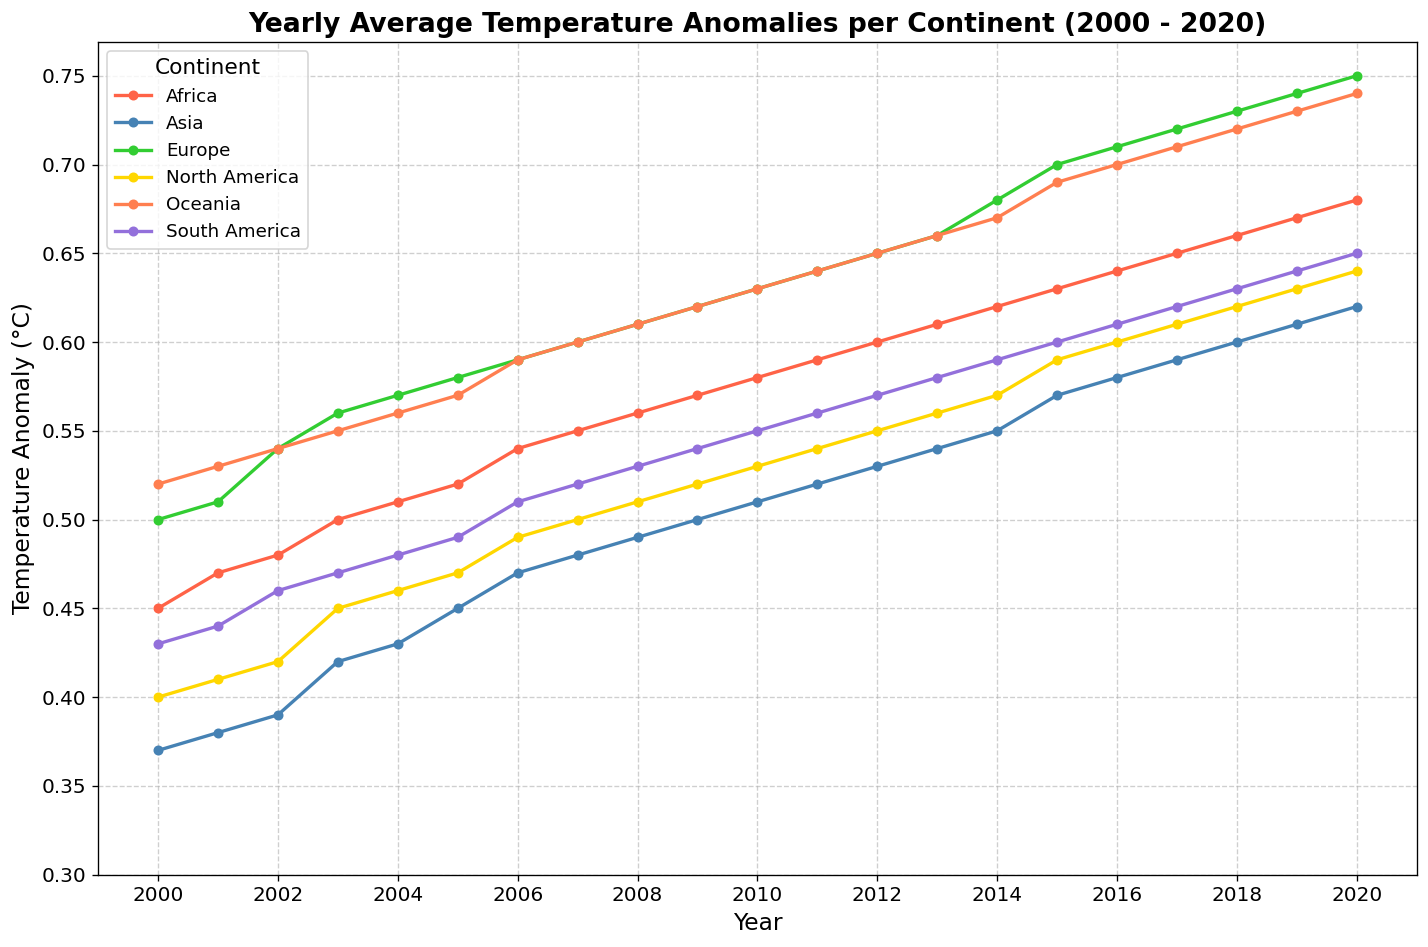What is the trend of the temperature anomaly in Africa from 2000 to 2020? The temperature anomaly in Africa shows a gradual increase over the years. Starting from 0.45 in 2000 and reaching 0.68 in 2020, the graph indicates a consistent upward trend.
Answer: Upward trend Which continent had the highest temperature anomaly in 2010? In 2010, Europe had the highest temperature anomaly, reaching 0.63, as seen from the plot where the green line (Europe) is the highest among all the continents for that year.
Answer: Europe How much did the temperature anomaly in Asia increase from 2000 to 2020? Asia's temperature anomaly increased from 0.37 in 2000 to 0.62 in 2020. The difference is 0.62 - 0.37 = 0.25.
Answer: 0.25 Compare the temperature anomaly between Oceania and South America in 2005. Which one was higher and by how much? In 2005, Oceania had a temperature anomaly of 0.57, whereas South America had 0.49. The difference is 0.57 - 0.49 = 0.08, making Oceania's anomaly higher.
Answer: Oceania by 0.08 Did any continent show a decrease in temperature anomaly from 2000 to 2020? No continent showed a decrease in temperature anomaly. All lines representing different continents indicate a rise from 2000 to 2020.
Answer: No What is the average temperature anomaly of South America over the 21 years? Summing the temperature anomalies of South America over the years from 0.43 (2000) to 0.65 (2020) and then dividing by the number of years (21), the average is [(0.43 + 0.44 + 0.46 + 0.47 + 0.48 + 0.49 + 0.51 + 0.52 + 0.53 + 0.54 + 0.55 + 0.56 + 0.57 + 0.58 + 0.59 + 0.60 + 0.61 + 0.62 + 0.63 + 0.64 + 0.65)/21] = 0.53
Answer: 0.53 In which year did Europe surpass the 0.70 temperature anomaly mark? Observing the green line for Europe, it surpasses the 0.70 mark in the year 2015, and maintains above that level until 2020.
Answer: 2015 Which continent has the steepest increase in temperature anomaly over the 21-year period? Africa shows the steepest increase going from 0.45 in 2000 to 0.68 in 2020, clearly visible from the slope of the red line being the steepest compared to other continents.
Answer: Africa What's the difference in the temperature anomaly between North America and Asia in 2010? In 2010, North America's temperature anomaly was 0.53 while Asia's was 0.51. The difference is 0.53 - 0.51 = 0.02.
Answer: 0.02 How many continents had a temperature anomaly of over 0.7 in the final year of the chart? In 2020, both Europe (0.75) and Oceania (0.74) had temperature anomalies over 0.7, as indicated by the lines in green and orange respectively crossing the 0.7 threshold.
Answer: 2 